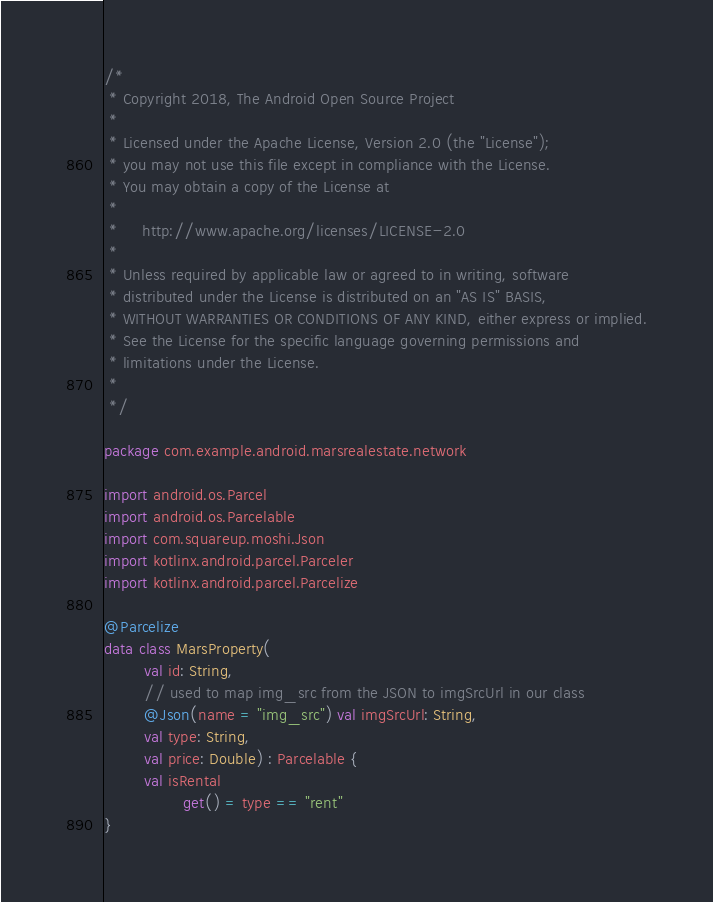Convert code to text. <code><loc_0><loc_0><loc_500><loc_500><_Kotlin_>/*
 * Copyright 2018, The Android Open Source Project
 *
 * Licensed under the Apache License, Version 2.0 (the "License");
 * you may not use this file except in compliance with the License.
 * You may obtain a copy of the License at
 *
 *     http://www.apache.org/licenses/LICENSE-2.0
 *
 * Unless required by applicable law or agreed to in writing, software
 * distributed under the License is distributed on an "AS IS" BASIS,
 * WITHOUT WARRANTIES OR CONDITIONS OF ANY KIND, either express or implied.
 * See the License for the specific language governing permissions and
 * limitations under the License.
 *
 */

package com.example.android.marsrealestate.network

import android.os.Parcel
import android.os.Parcelable
import com.squareup.moshi.Json
import kotlinx.android.parcel.Parceler
import kotlinx.android.parcel.Parcelize

@Parcelize
data class MarsProperty(
        val id: String,
        // used to map img_src from the JSON to imgSrcUrl in our class
        @Json(name = "img_src") val imgSrcUrl: String,
        val type: String,
        val price: Double) : Parcelable {
        val isRental
                get() = type == "rent"
}

</code> 